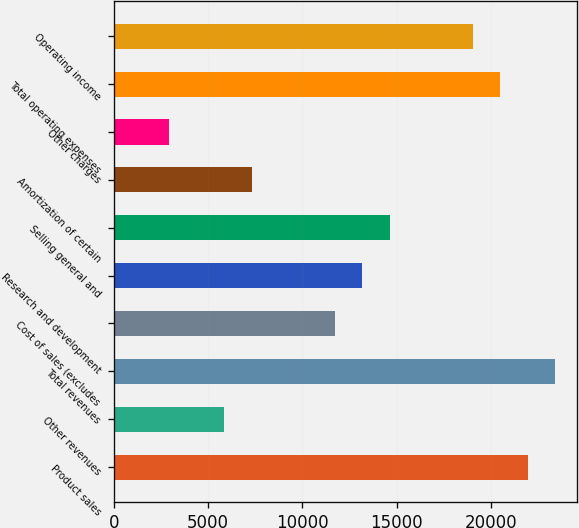Convert chart. <chart><loc_0><loc_0><loc_500><loc_500><bar_chart><fcel>Product sales<fcel>Other revenues<fcel>Total revenues<fcel>Cost of sales (excludes<fcel>Research and development<fcel>Selling general and<fcel>Amortization of certain<fcel>Other charges<fcel>Total operating expenses<fcel>Operating income<nl><fcel>21960.8<fcel>5859.51<fcel>23424.5<fcel>11714.5<fcel>13178.3<fcel>14642<fcel>7323.26<fcel>2932.01<fcel>20497<fcel>19033.3<nl></chart> 